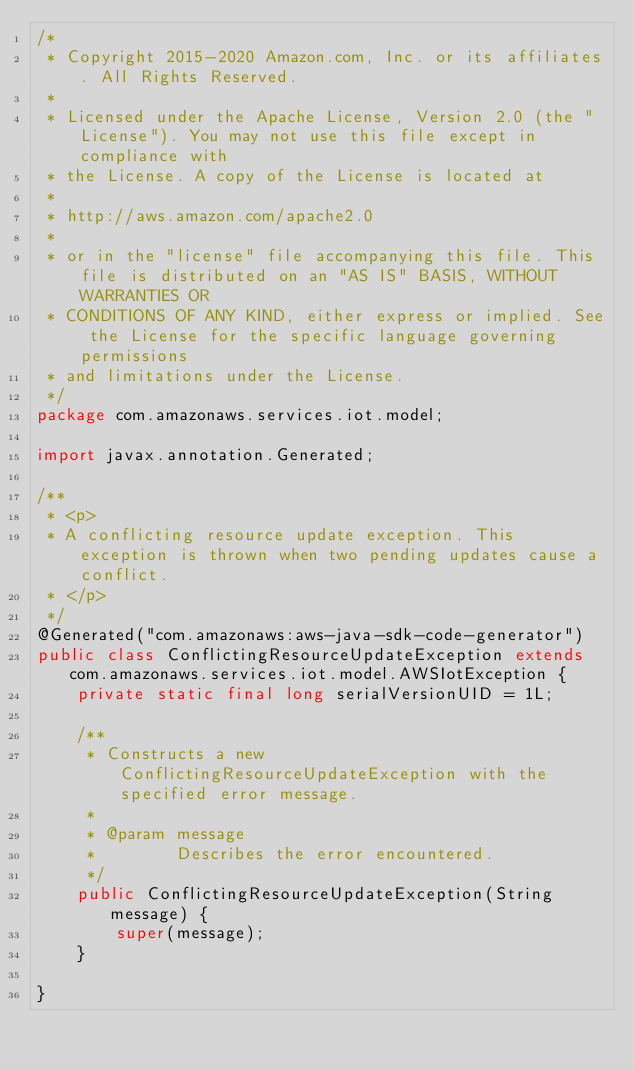<code> <loc_0><loc_0><loc_500><loc_500><_Java_>/*
 * Copyright 2015-2020 Amazon.com, Inc. or its affiliates. All Rights Reserved.
 * 
 * Licensed under the Apache License, Version 2.0 (the "License"). You may not use this file except in compliance with
 * the License. A copy of the License is located at
 * 
 * http://aws.amazon.com/apache2.0
 * 
 * or in the "license" file accompanying this file. This file is distributed on an "AS IS" BASIS, WITHOUT WARRANTIES OR
 * CONDITIONS OF ANY KIND, either express or implied. See the License for the specific language governing permissions
 * and limitations under the License.
 */
package com.amazonaws.services.iot.model;

import javax.annotation.Generated;

/**
 * <p>
 * A conflicting resource update exception. This exception is thrown when two pending updates cause a conflict.
 * </p>
 */
@Generated("com.amazonaws:aws-java-sdk-code-generator")
public class ConflictingResourceUpdateException extends com.amazonaws.services.iot.model.AWSIotException {
    private static final long serialVersionUID = 1L;

    /**
     * Constructs a new ConflictingResourceUpdateException with the specified error message.
     *
     * @param message
     *        Describes the error encountered.
     */
    public ConflictingResourceUpdateException(String message) {
        super(message);
    }

}
</code> 